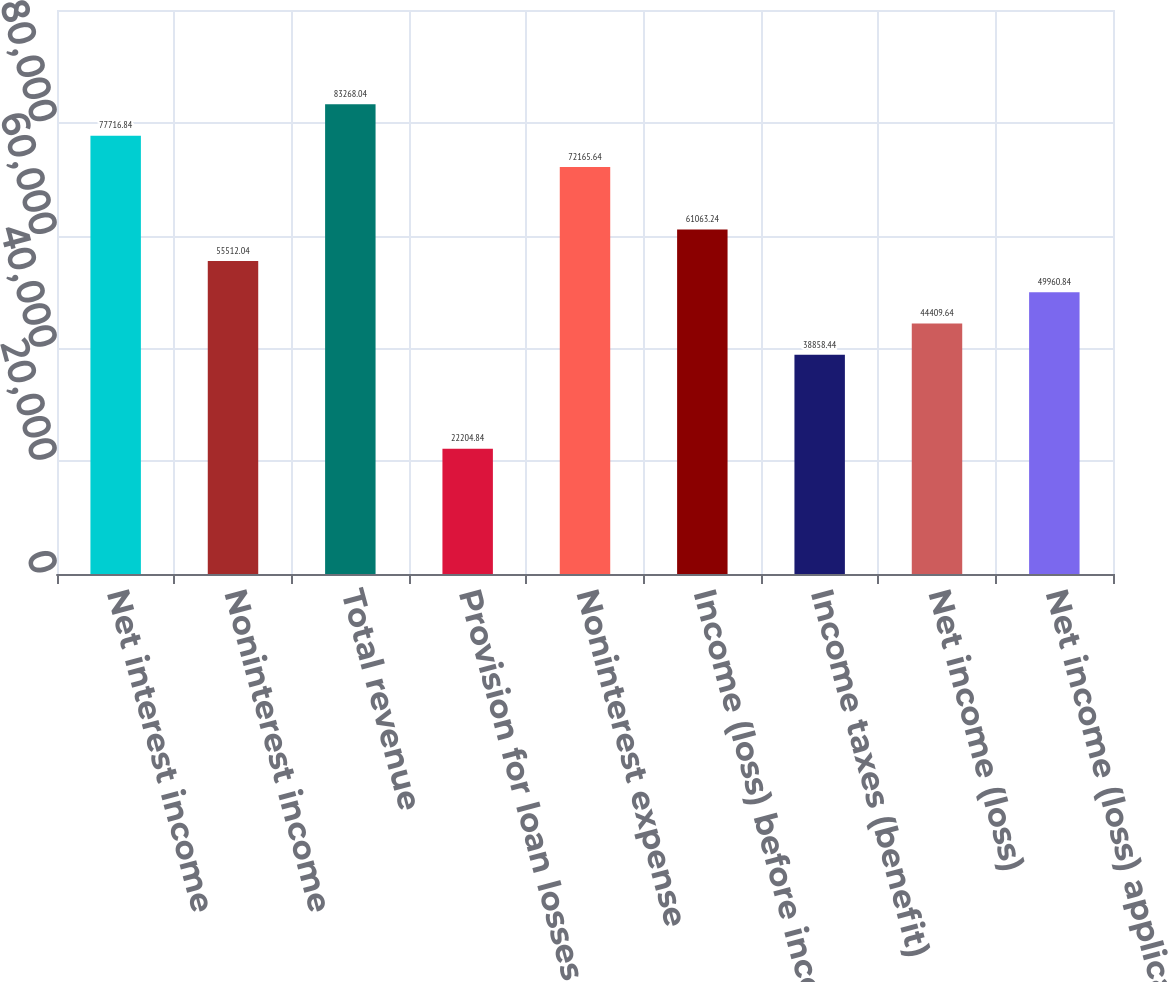<chart> <loc_0><loc_0><loc_500><loc_500><bar_chart><fcel>Net interest income<fcel>Noninterest income<fcel>Total revenue<fcel>Provision for loan losses<fcel>Noninterest expense<fcel>Income (loss) before income<fcel>Income taxes (benefit)<fcel>Net income (loss)<fcel>Net income (loss) applicable<nl><fcel>77716.8<fcel>55512<fcel>83268<fcel>22204.8<fcel>72165.6<fcel>61063.2<fcel>38858.4<fcel>44409.6<fcel>49960.8<nl></chart> 